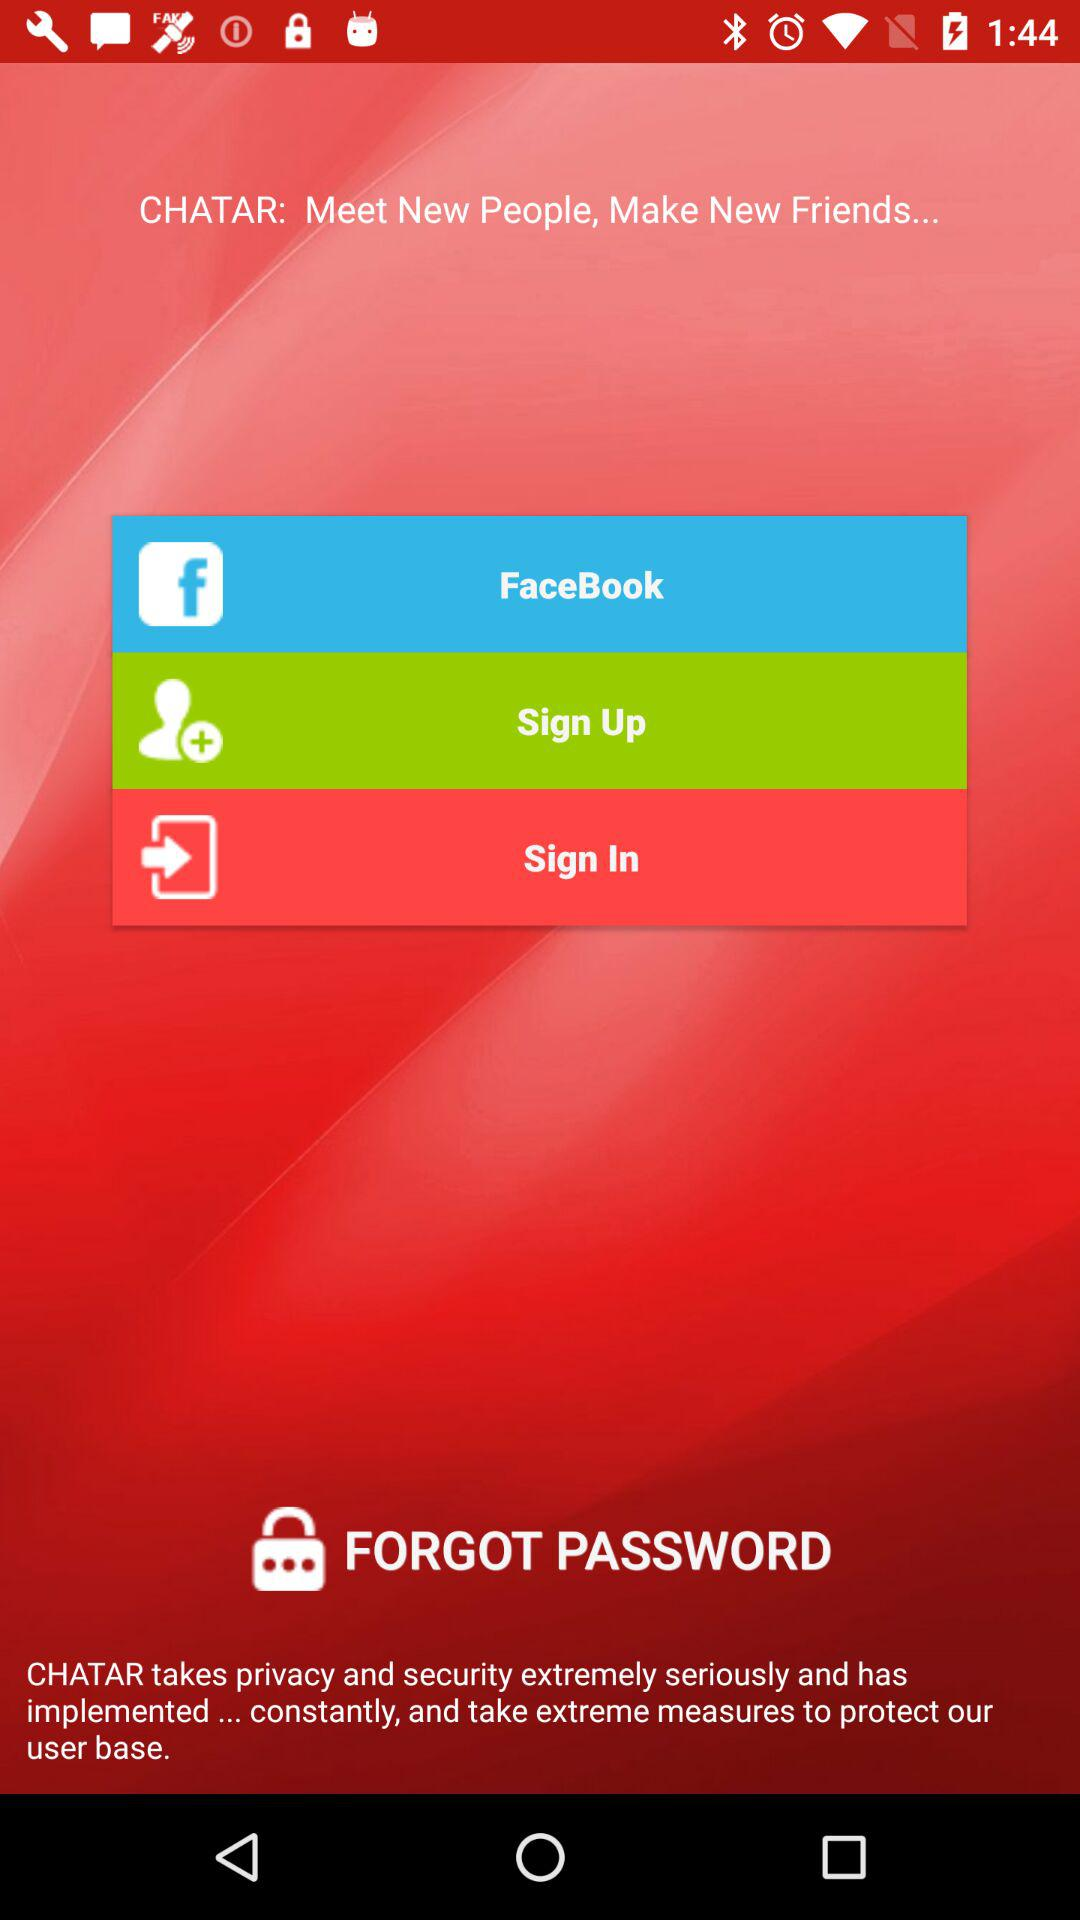What is the application name? The application name is "CHATAR". 